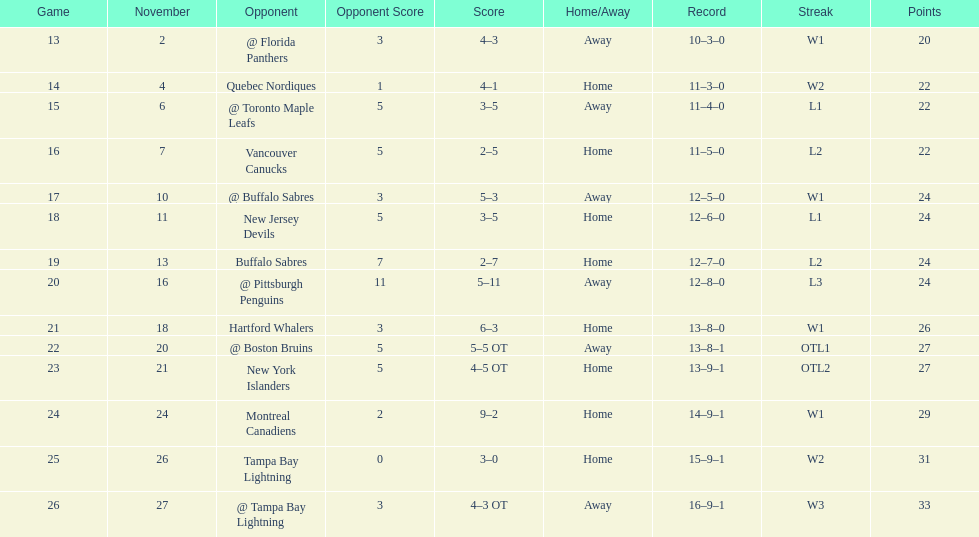The 1993-1994 flyers missed the playoffs again. how many consecutive seasons up until 93-94 did the flyers miss the playoffs? 5. 